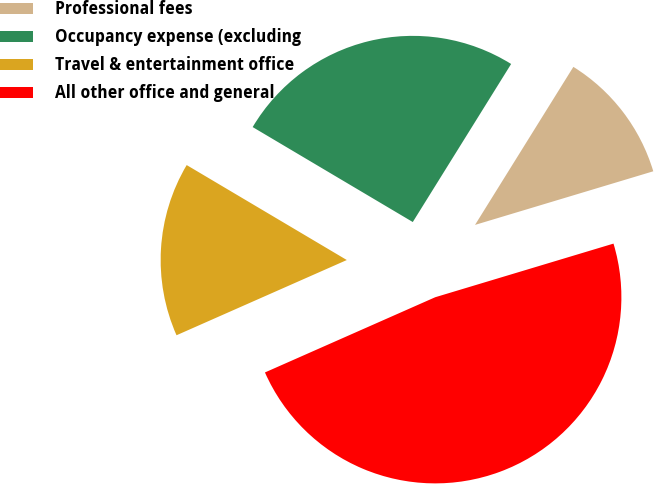<chart> <loc_0><loc_0><loc_500><loc_500><pie_chart><fcel>Professional fees<fcel>Occupancy expense (excluding<fcel>Travel & entertainment office<fcel>All other office and general<nl><fcel>11.49%<fcel>25.34%<fcel>15.14%<fcel>48.03%<nl></chart> 